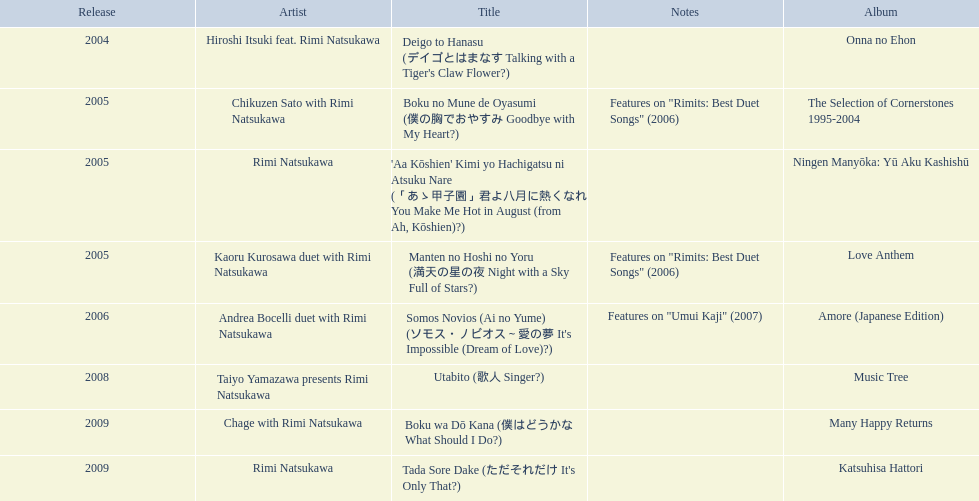What are the entire set of titles? Deigo to Hanasu (デイゴとはまなす Talking with a Tiger's Claw Flower?), Boku no Mune de Oyasumi (僕の胸でおやすみ Goodbye with My Heart?), 'Aa Kōshien' Kimi yo Hachigatsu ni Atsuku Nare (「あゝ甲子園」君よ八月に熱くなれ You Make Me Hot in August (from Ah, Kōshien)?), Manten no Hoshi no Yoru (満天の星の夜 Night with a Sky Full of Stars?), Somos Novios (Ai no Yume) (ソモス・ノビオス～愛の夢 It's Impossible (Dream of Love)?), Utabito (歌人 Singer?), Boku wa Dō Kana (僕はどうかな What Should I Do?), Tada Sore Dake (ただそれだけ It's Only That?). What are their annotations? , Features on "Rimits: Best Duet Songs" (2006), , Features on "Rimits: Best Duet Songs" (2006), Features on "Umui Kaji" (2007), , , . Which title possesses the same notes as "manten no hoshi no yoru" (man tian noxing noye night with a sky full of stars)? Boku no Mune de Oyasumi (僕の胸でおやすみ Goodbye with My Heart?). 